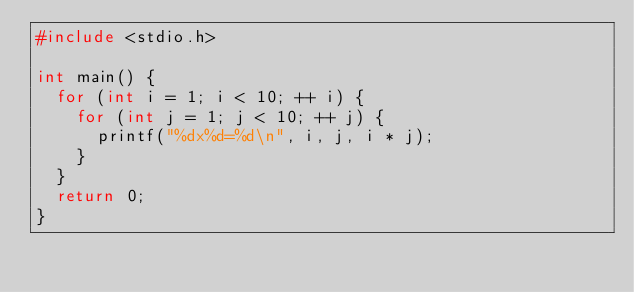Convert code to text. <code><loc_0><loc_0><loc_500><loc_500><_C_>#include <stdio.h>

int main() {
	for (int i = 1; i < 10; ++ i) {
		for (int j = 1; j < 10; ++ j) {
			printf("%dx%d=%d\n", i, j, i * j);
		}
	}
	return 0;
}</code> 